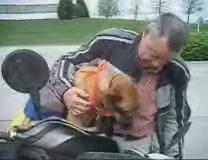What color is the dog?
Answer briefly. Brown. Is this man riding with his dog?
Be succinct. Yes. Is the man wearing a jacket?
Give a very brief answer. Yes. 